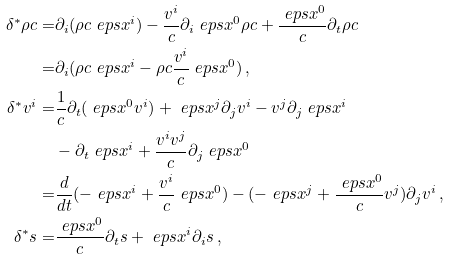Convert formula to latex. <formula><loc_0><loc_0><loc_500><loc_500>\delta ^ { * } \rho c = & \partial _ { i } ( \rho c \ e p s x ^ { i } ) - \frac { v ^ { i } } { c } \partial _ { i } \ e p s x ^ { 0 } \rho c + \frac { \ e p s x ^ { 0 } } { c } \partial _ { t } \rho c \\ = & \partial _ { i } ( \rho c \ e p s x ^ { i } - \rho c \frac { v ^ { i } } { c } \ e p s x ^ { 0 } ) \, , \\ \delta ^ { * } v ^ { i } = & \frac { 1 } { c } \partial _ { t } ( \ e p s x ^ { 0 } v ^ { i } ) + \ e p s x ^ { j } \partial _ { j } v ^ { i } - v ^ { j } \partial _ { j } \ e p s x ^ { i } \\ & - \partial _ { t } \ e p s x ^ { i } + \frac { v ^ { i } v ^ { j } } { c } \partial _ { j } \ e p s x ^ { 0 } \\ = & \frac { d } { d t } ( - \ e p s x ^ { i } + \frac { v ^ { i } } { c } \ e p s x ^ { 0 } ) - ( - \ e p s x ^ { j } + \frac { \ e p s x ^ { 0 } } { c } v ^ { j } ) \partial _ { j } v ^ { i } \, , \\ \delta ^ { * } s = & \frac { \ e p s x ^ { 0 } } { c } \partial _ { t } s + \ e p s x ^ { i } \partial _ { i } s \, ,</formula> 